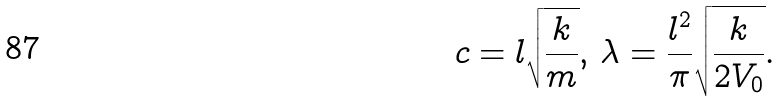<formula> <loc_0><loc_0><loc_500><loc_500>c = l \sqrt { \frac { k } { m } } , \, \lambda = \frac { l ^ { 2 } } { \pi } \sqrt { \frac { k } { 2 V _ { 0 } } } .</formula> 